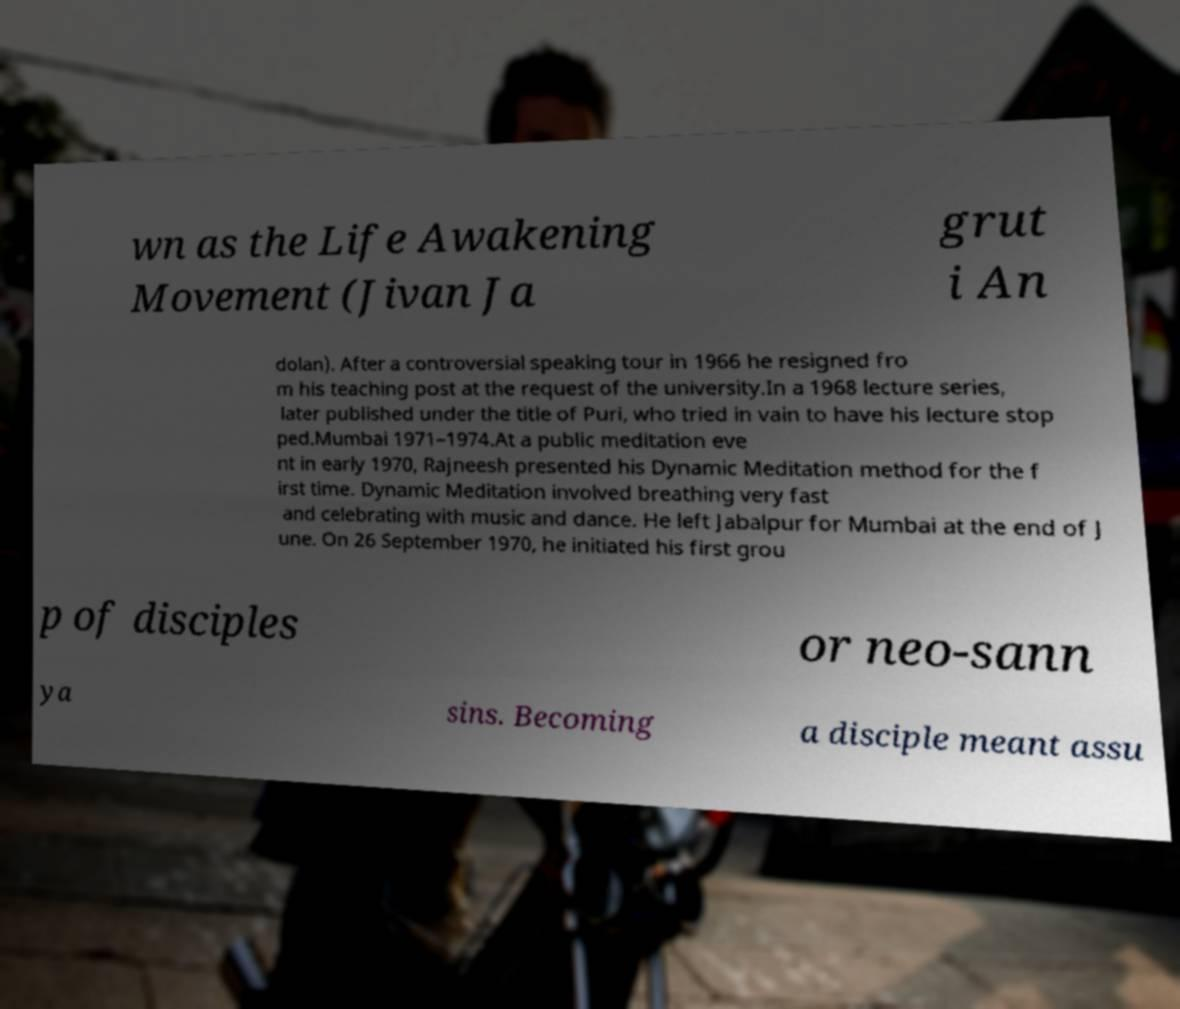Please read and relay the text visible in this image. What does it say? wn as the Life Awakening Movement (Jivan Ja grut i An dolan). After a controversial speaking tour in 1966 he resigned fro m his teaching post at the request of the university.In a 1968 lecture series, later published under the title of Puri, who tried in vain to have his lecture stop ped.Mumbai 1971–1974.At a public meditation eve nt in early 1970, Rajneesh presented his Dynamic Meditation method for the f irst time. Dynamic Meditation involved breathing very fast and celebrating with music and dance. He left Jabalpur for Mumbai at the end of J une. On 26 September 1970, he initiated his first grou p of disciples or neo-sann ya sins. Becoming a disciple meant assu 